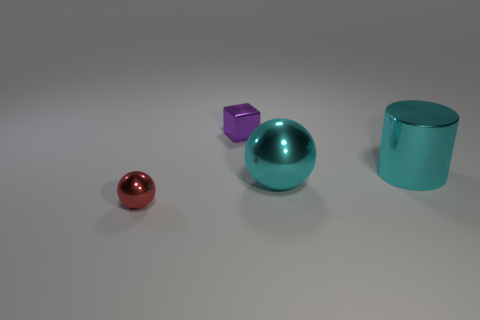Is the material of the large cyan ball the same as the purple cube? From a visual inspection of the image, it appears that the surfaces of the large cyan ball and the purple cube have different textures and reflections, suggesting that they may be made of different materials. The cyan ball has a smoother and more reflective surface, while the purple cube seems to have a more matte finish. 